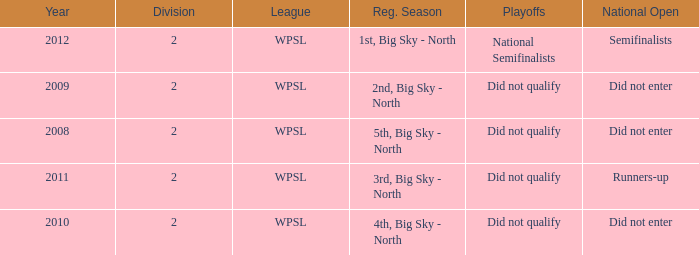What is the lowest division number? 2.0. 